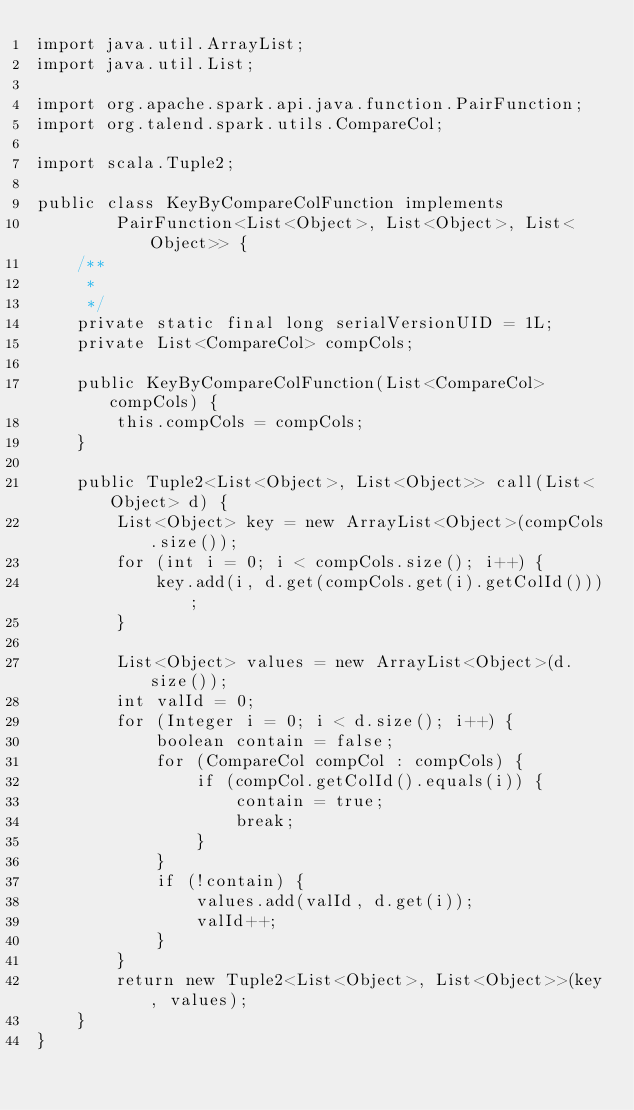Convert code to text. <code><loc_0><loc_0><loc_500><loc_500><_Java_>import java.util.ArrayList;
import java.util.List;

import org.apache.spark.api.java.function.PairFunction;
import org.talend.spark.utils.CompareCol;

import scala.Tuple2;

public class KeyByCompareColFunction implements
		PairFunction<List<Object>, List<Object>, List<Object>> {
	/**
	 * 
	 */
	private static final long serialVersionUID = 1L;
	private List<CompareCol> compCols;

	public KeyByCompareColFunction(List<CompareCol> compCols) {
		this.compCols = compCols;
	}

	public Tuple2<List<Object>, List<Object>> call(List<Object> d) {
		List<Object> key = new ArrayList<Object>(compCols.size());
		for (int i = 0; i < compCols.size(); i++) {
			key.add(i, d.get(compCols.get(i).getColId()));
		}

		List<Object> values = new ArrayList<Object>(d.size());
		int valId = 0;
		for (Integer i = 0; i < d.size(); i++) {
			boolean contain = false;
			for (CompareCol compCol : compCols) {
				if (compCol.getColId().equals(i)) {
					contain = true;
					break;
				}
			}
			if (!contain) {
				values.add(valId, d.get(i));
				valId++;
			}
		}
		return new Tuple2<List<Object>, List<Object>>(key, values);
	}
}
</code> 